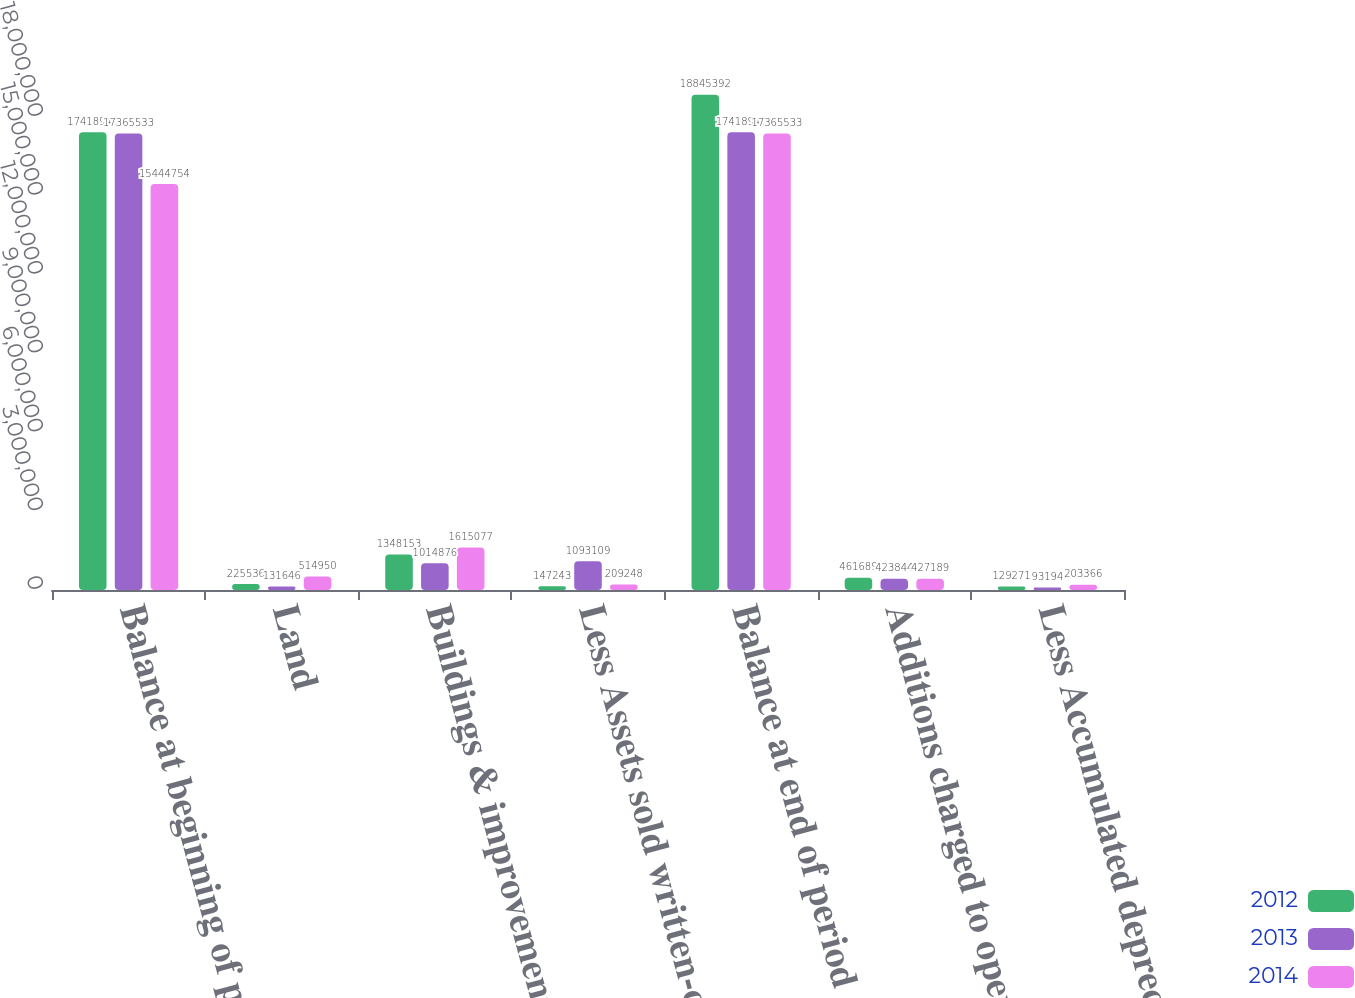Convert chart to OTSL. <chart><loc_0><loc_0><loc_500><loc_500><stacked_bar_chart><ecel><fcel>Balance at beginning of period<fcel>Land<fcel>Buildings & improvements<fcel>Less Assets sold written-off<fcel>Balance at end of period<fcel>Additions charged to operating<fcel>Less Accumulated depreciation<nl><fcel>2012<fcel>1.74189e+07<fcel>225536<fcel>1.34815e+06<fcel>147243<fcel>1.88454e+07<fcel>461689<fcel>129271<nl><fcel>2013<fcel>1.73655e+07<fcel>131646<fcel>1.01488e+06<fcel>1.09311e+06<fcel>1.74189e+07<fcel>423844<fcel>93194<nl><fcel>2014<fcel>1.54448e+07<fcel>514950<fcel>1.61508e+06<fcel>209248<fcel>1.73655e+07<fcel>427189<fcel>203366<nl></chart> 